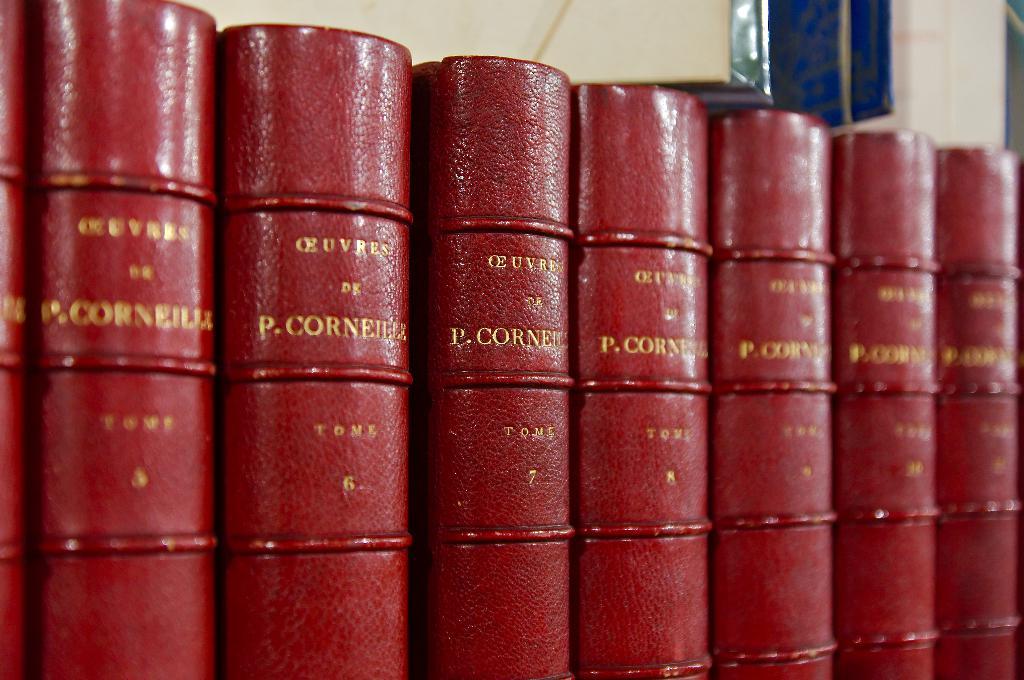Who wrote these books?
Keep it short and to the point. P. corneille. 